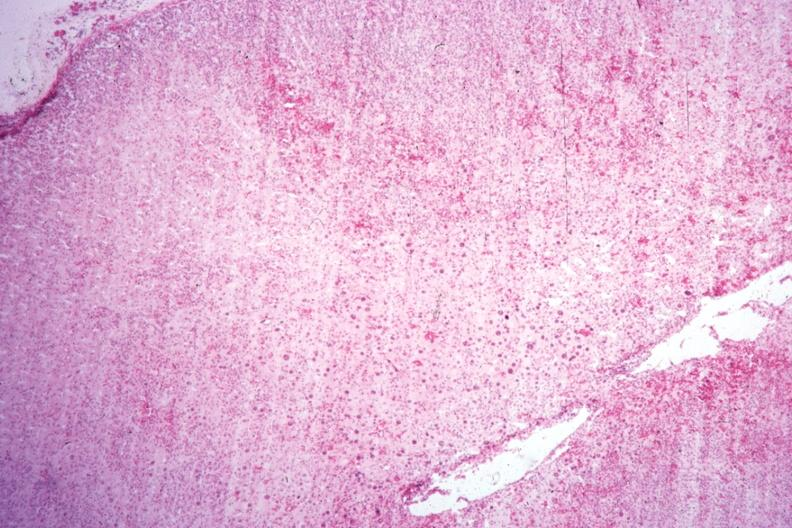what is present?
Answer the question using a single word or phrase. Endocrine 